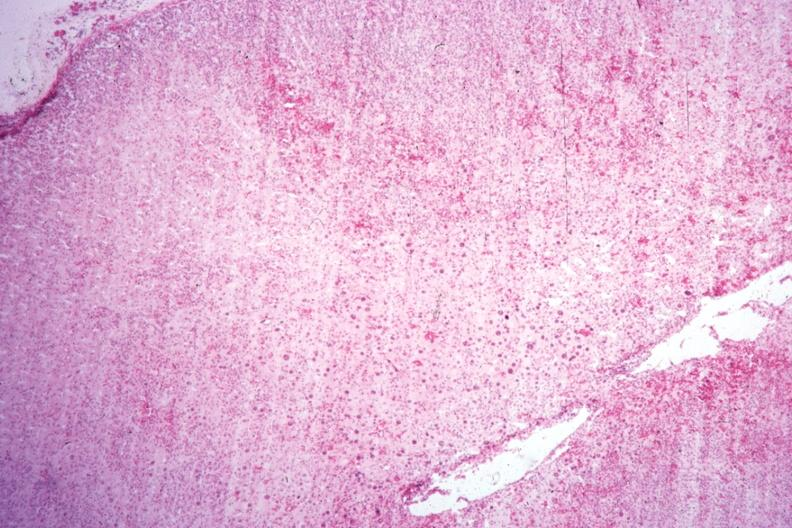what is present?
Answer the question using a single word or phrase. Endocrine 